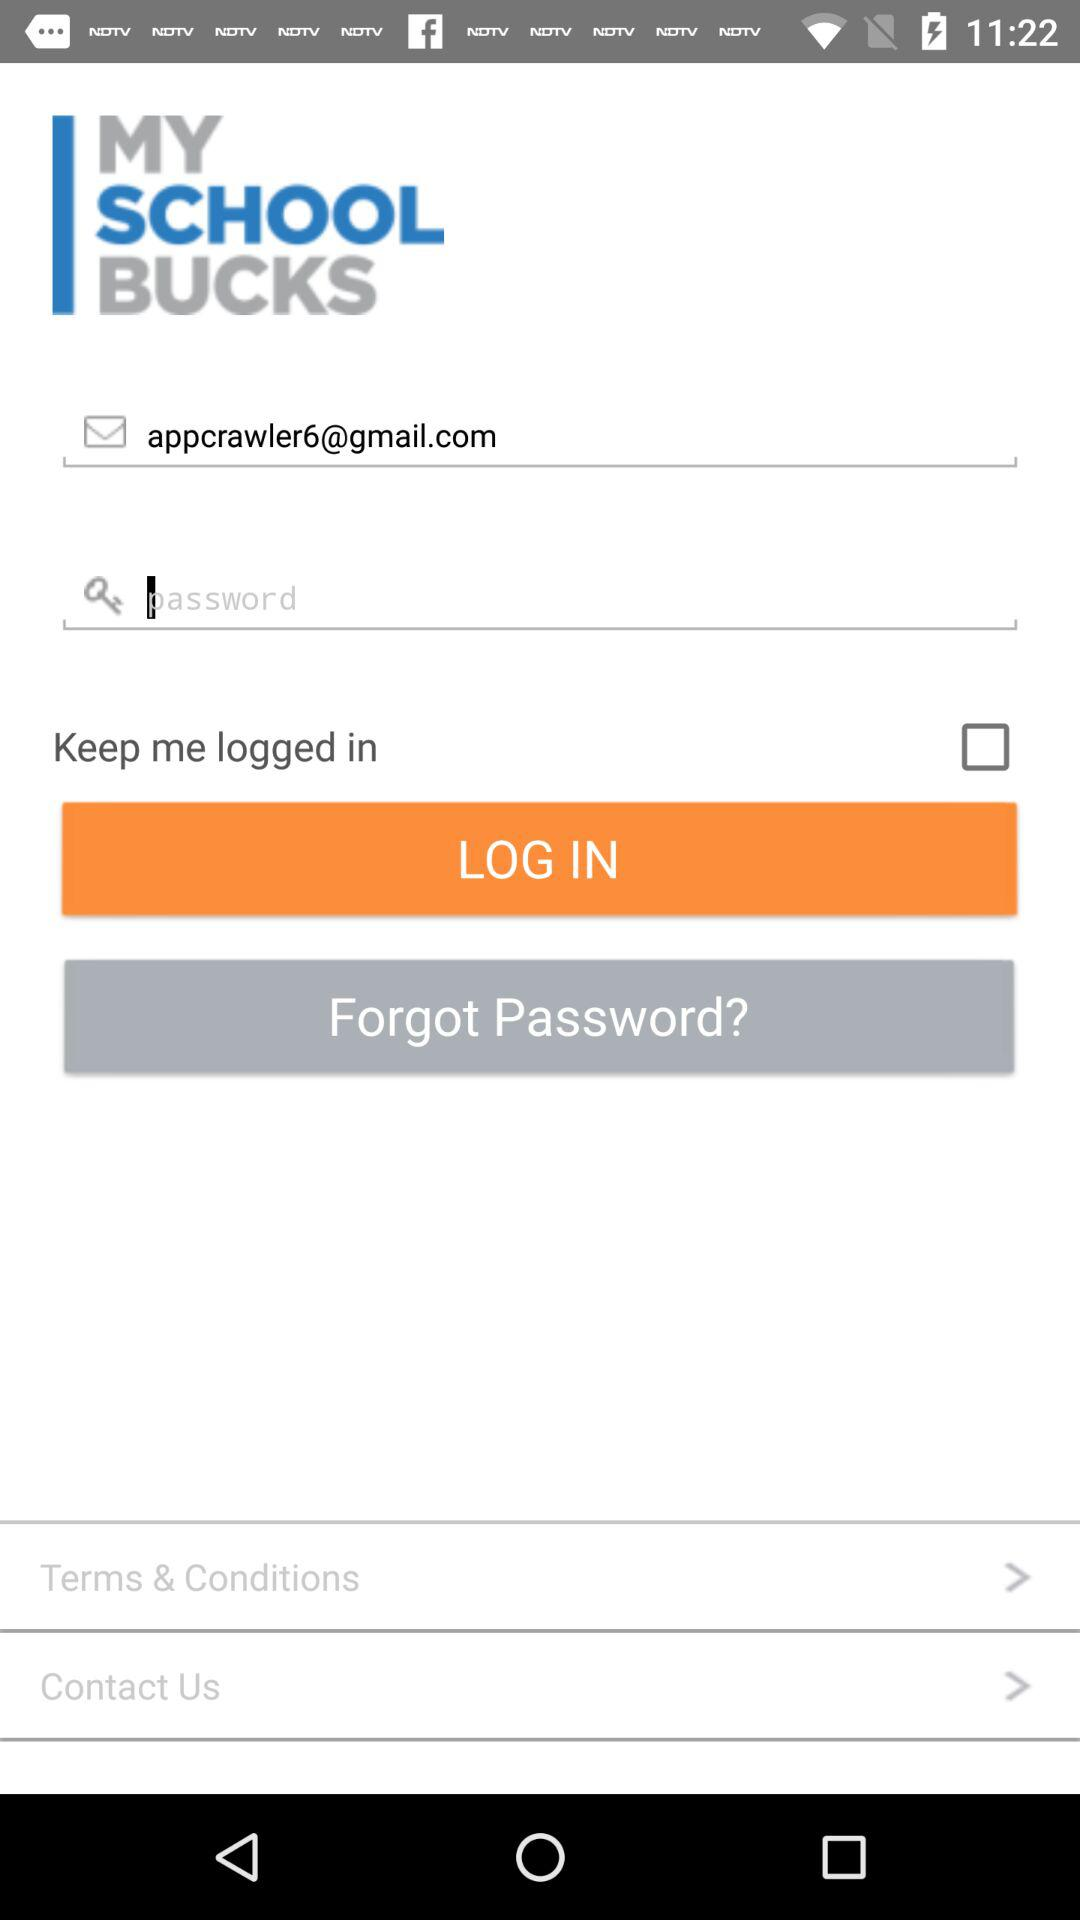What is the status of "Keep me logged in"? The status is "off". 